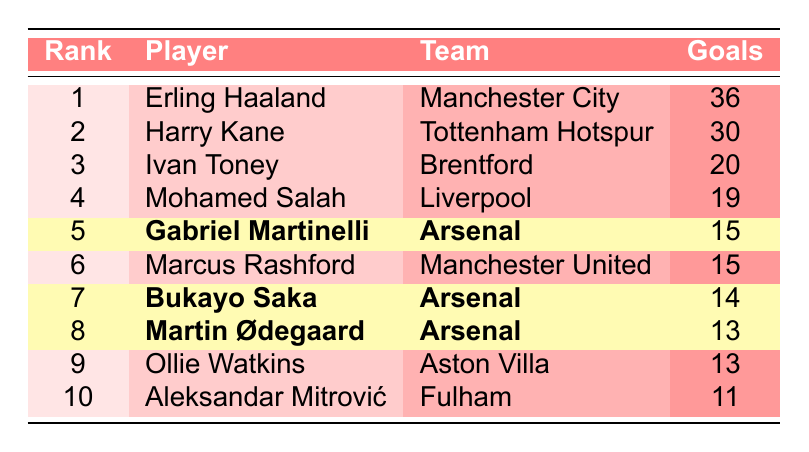What is the highest number of goals scored by a player in the table? The highest number of goals is found in the first row, which lists Erling Haaland with 36 goals.
Answer: 36 Which teams have players listed in the top 5 goal scorers? The top 5 goal scorers are from Manchester City (Erling Haaland), Tottenham Hotspur (Harry Kane), Brentford (Ivan Toney), Liverpool (Mohamed Salah), and Arsenal (Gabriel Martinelli). Thus, the teams are Manchester City, Tottenham Hotspur, Brentford, Liverpool, and Arsenal.
Answer: Manchester City, Tottenham Hotspur, Brentford, Liverpool, Arsenal How many goals did Arsenal players score combined in the table? Gabriel Martinelli scored 15 goals, Bukayo Saka scored 14 goals, and Martin Ødegaard scored 13 goals. Adding these gives a total of 15 + 14 + 13 = 42 goals.
Answer: 42 Is Mohamed Salah listed among the top 5 goal scorers? Mohamed Salah is ranked 4th in the table with 19 goals, which places him within the top 5 goal scorers.
Answer: Yes What is the difference in goals scored between the top scorer and the fifth scorer? The top scorer, Erling Haaland, scored 36 goals, while the fifth scorer, Gabriel Martinelli, scored 15 goals. Therefore, the difference is 36 - 15 = 21.
Answer: 21 How many players in the table scored 15 goals? There are two players with 15 goals: Gabriel Martinelli and Marcus Rashford. Counting them, we find there are 2 players.
Answer: 2 What is the average number of goals scored by the top 10 players in the table? To find the average, we first sum the goals: 36 + 30 + 20 + 19 + 15 + 15 + 14 + 13 + 13 + 11 =  252. There are 10 players, so the average is 252 / 10 = 25.2.
Answer: 25.2 Did any player score the same number of goals as the player in 10th place? The player in 10th place, Aleksandar Mitrović, scored 11 goals. Comparing this to the others, no player has scored exactly 11 goals, so the answer is no.
Answer: No 